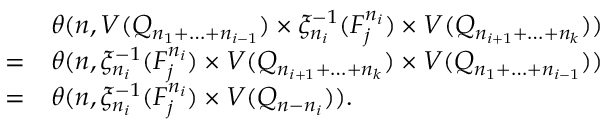<formula> <loc_0><loc_0><loc_500><loc_500>\begin{array} { r c l } & & { \theta ( n , V ( Q _ { n _ { 1 } + \dots + n _ { i - 1 } } ) \times \xi _ { n _ { i } } ^ { - 1 } ( F _ { j } ^ { n _ { i } } ) \times V ( Q _ { n _ { i + 1 } + \dots + n _ { k } } ) ) } \\ & { = } & { \theta ( n , \xi _ { n _ { i } } ^ { - 1 } ( F _ { j } ^ { n _ { i } } ) \times V ( Q _ { n _ { i + 1 } + \dots + n _ { k } } ) \times V ( Q _ { n _ { 1 } + \dots + n _ { i - 1 } } ) ) } \\ & { = } & { \theta ( n , \xi _ { n _ { i } } ^ { - 1 } ( F _ { j } ^ { n _ { i } } ) \times V ( Q _ { n - n _ { i } } ) ) . } \end{array}</formula> 